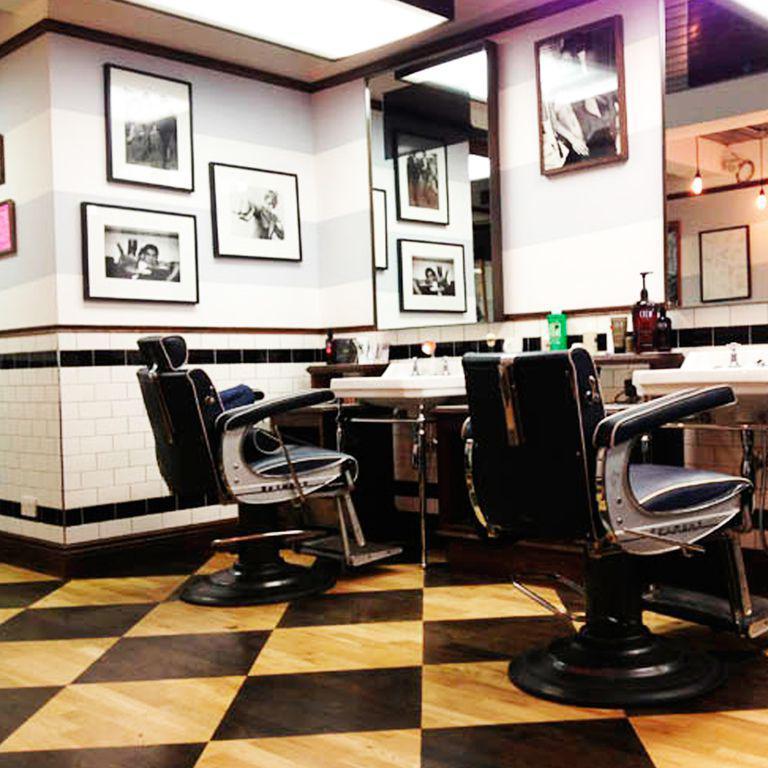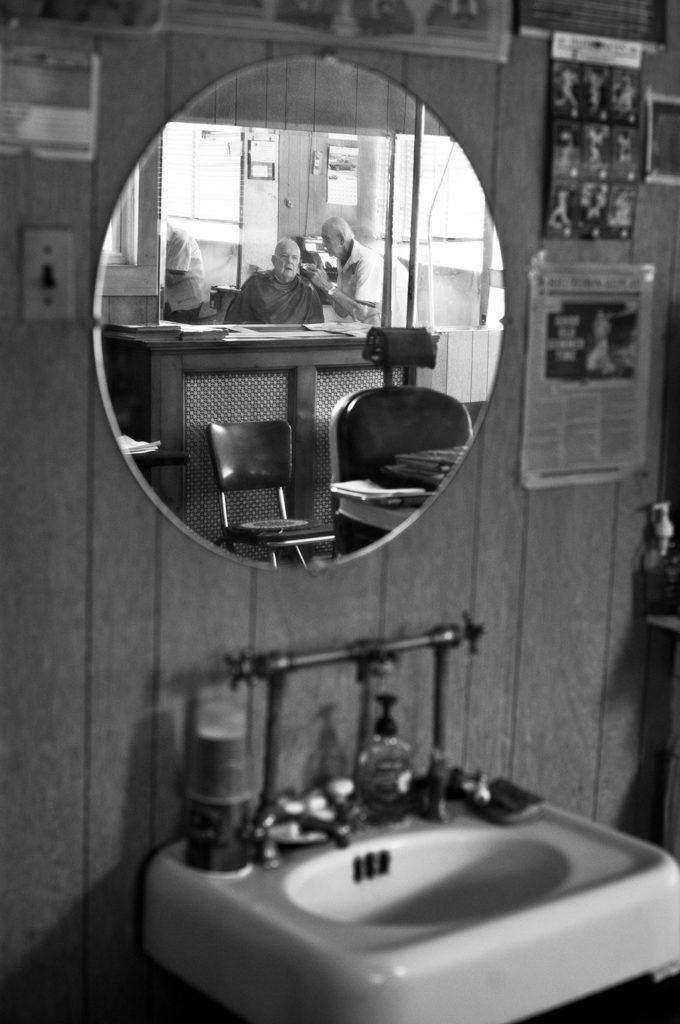The first image is the image on the left, the second image is the image on the right. Examine the images to the left and right. Is the description "A floor has a checkered pattern." accurate? Answer yes or no. Yes. 